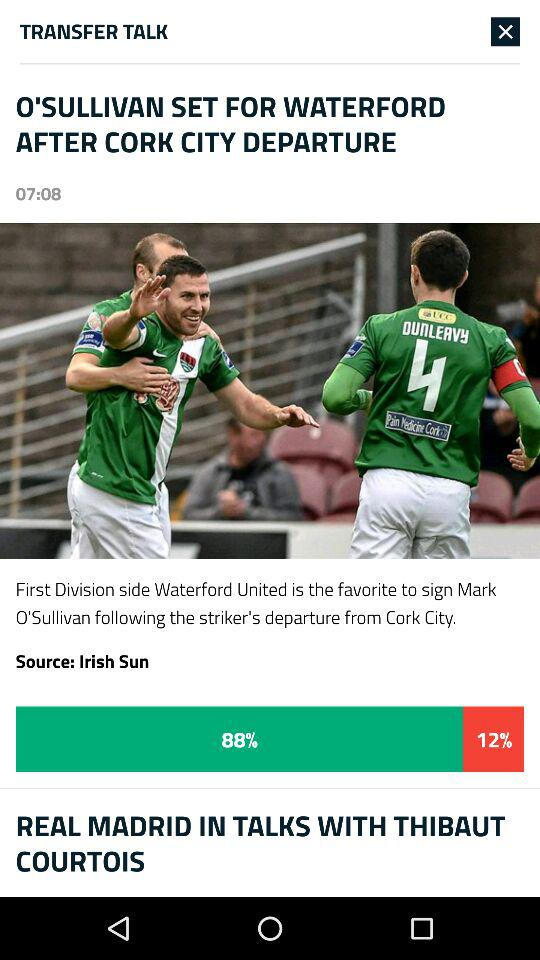What is the source of the article "O'SULLIVAN SET FOR WATERFORD AFTER CORK CITY DEPARTURE"? The source of the article "O'SULLIVAN SET FOR WATERFORD AFTER CORK CITY DEPARTURE" is "Irish Sun". 